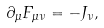<formula> <loc_0><loc_0><loc_500><loc_500>\partial _ { \mu } F _ { \mu \nu } = - J _ { \nu } ,</formula> 